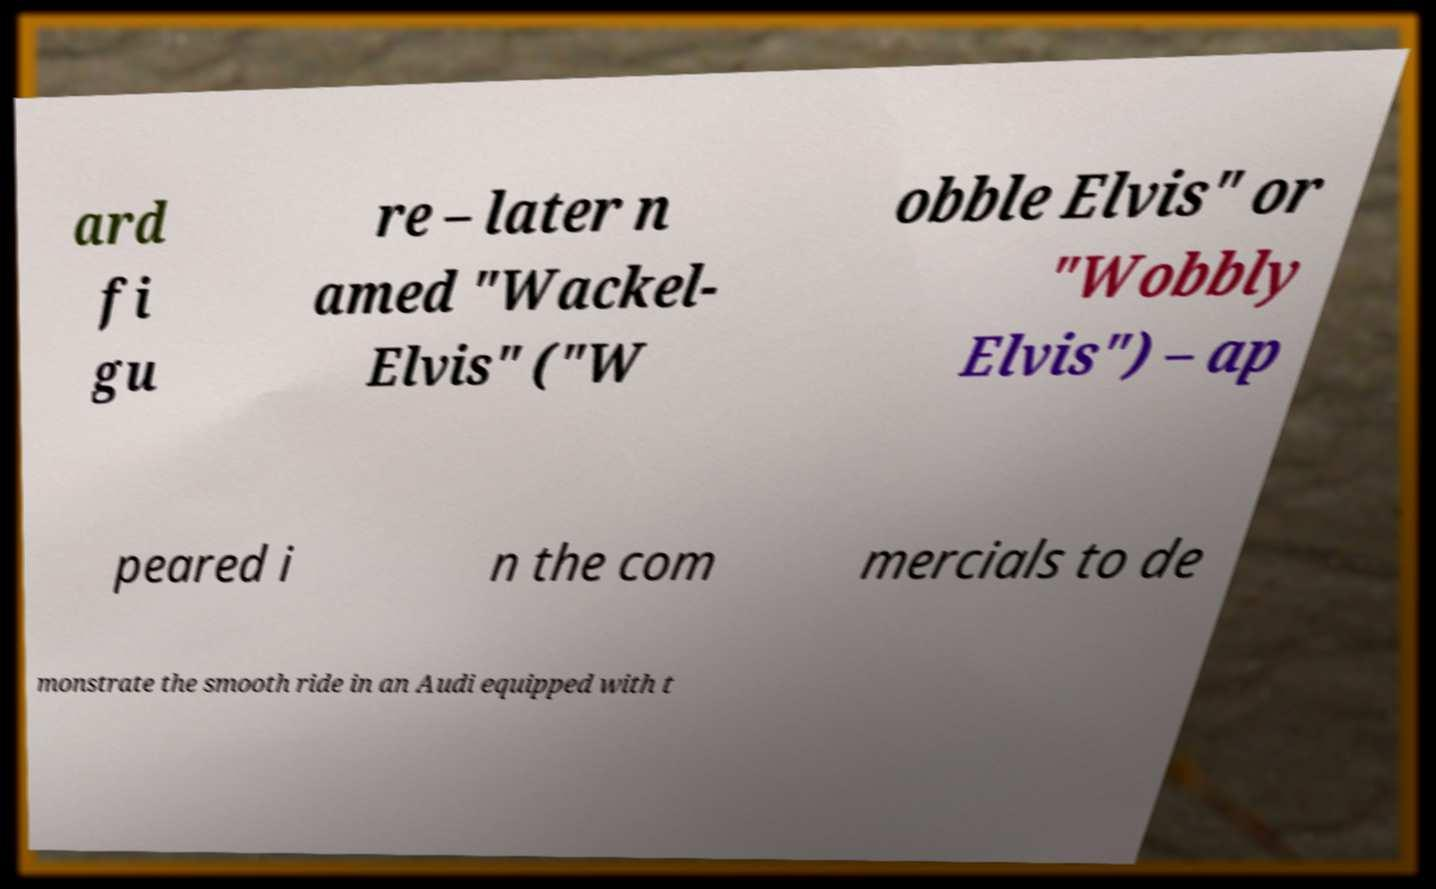I need the written content from this picture converted into text. Can you do that? ard fi gu re – later n amed "Wackel- Elvis" ("W obble Elvis" or "Wobbly Elvis") – ap peared i n the com mercials to de monstrate the smooth ride in an Audi equipped with t 